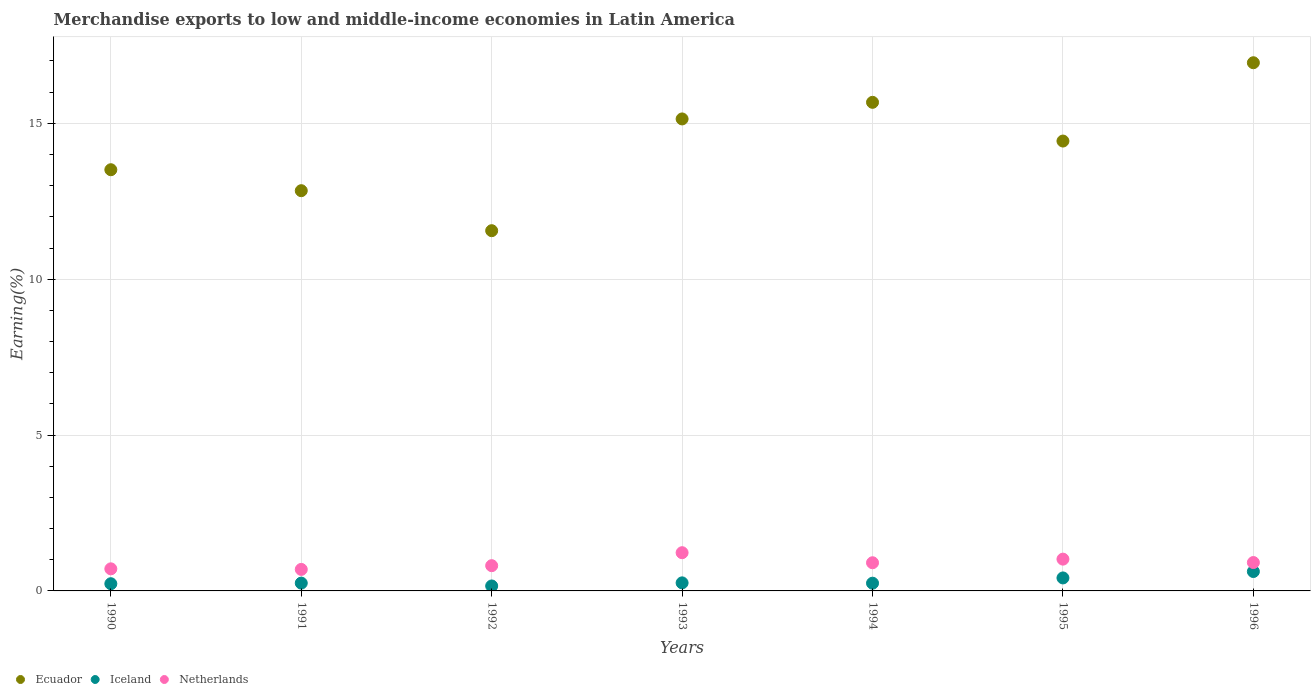How many different coloured dotlines are there?
Offer a very short reply. 3. What is the percentage of amount earned from merchandise exports in Netherlands in 1995?
Give a very brief answer. 1.02. Across all years, what is the maximum percentage of amount earned from merchandise exports in Ecuador?
Keep it short and to the point. 16.94. Across all years, what is the minimum percentage of amount earned from merchandise exports in Iceland?
Make the answer very short. 0.16. What is the total percentage of amount earned from merchandise exports in Iceland in the graph?
Ensure brevity in your answer.  2.19. What is the difference between the percentage of amount earned from merchandise exports in Ecuador in 1990 and that in 1994?
Offer a very short reply. -2.16. What is the difference between the percentage of amount earned from merchandise exports in Iceland in 1995 and the percentage of amount earned from merchandise exports in Ecuador in 1990?
Ensure brevity in your answer.  -13.1. What is the average percentage of amount earned from merchandise exports in Netherlands per year?
Offer a very short reply. 0.9. In the year 1995, what is the difference between the percentage of amount earned from merchandise exports in Ecuador and percentage of amount earned from merchandise exports in Netherlands?
Give a very brief answer. 13.41. What is the ratio of the percentage of amount earned from merchandise exports in Iceland in 1992 to that in 1996?
Your answer should be compact. 0.26. Is the percentage of amount earned from merchandise exports in Iceland in 1991 less than that in 1994?
Make the answer very short. No. What is the difference between the highest and the second highest percentage of amount earned from merchandise exports in Ecuador?
Ensure brevity in your answer.  1.27. What is the difference between the highest and the lowest percentage of amount earned from merchandise exports in Ecuador?
Your answer should be very brief. 5.39. In how many years, is the percentage of amount earned from merchandise exports in Netherlands greater than the average percentage of amount earned from merchandise exports in Netherlands taken over all years?
Keep it short and to the point. 4. Is the sum of the percentage of amount earned from merchandise exports in Netherlands in 1995 and 1996 greater than the maximum percentage of amount earned from merchandise exports in Ecuador across all years?
Your answer should be compact. No. Does the percentage of amount earned from merchandise exports in Iceland monotonically increase over the years?
Provide a succinct answer. No. Is the percentage of amount earned from merchandise exports in Ecuador strictly less than the percentage of amount earned from merchandise exports in Iceland over the years?
Make the answer very short. No. How many dotlines are there?
Make the answer very short. 3. Are the values on the major ticks of Y-axis written in scientific E-notation?
Give a very brief answer. No. Does the graph contain any zero values?
Your answer should be very brief. No. Where does the legend appear in the graph?
Keep it short and to the point. Bottom left. How many legend labels are there?
Give a very brief answer. 3. What is the title of the graph?
Offer a terse response. Merchandise exports to low and middle-income economies in Latin America. What is the label or title of the Y-axis?
Your response must be concise. Earning(%). What is the Earning(%) of Ecuador in 1990?
Your response must be concise. 13.51. What is the Earning(%) of Iceland in 1990?
Your answer should be compact. 0.23. What is the Earning(%) in Netherlands in 1990?
Provide a short and direct response. 0.71. What is the Earning(%) in Ecuador in 1991?
Your answer should be very brief. 12.84. What is the Earning(%) of Iceland in 1991?
Your answer should be very brief. 0.25. What is the Earning(%) in Netherlands in 1991?
Your answer should be compact. 0.69. What is the Earning(%) in Ecuador in 1992?
Give a very brief answer. 11.56. What is the Earning(%) of Iceland in 1992?
Provide a succinct answer. 0.16. What is the Earning(%) in Netherlands in 1992?
Your answer should be compact. 0.81. What is the Earning(%) in Ecuador in 1993?
Your answer should be very brief. 15.14. What is the Earning(%) in Iceland in 1993?
Offer a very short reply. 0.26. What is the Earning(%) in Netherlands in 1993?
Ensure brevity in your answer.  1.23. What is the Earning(%) of Ecuador in 1994?
Offer a terse response. 15.67. What is the Earning(%) in Iceland in 1994?
Keep it short and to the point. 0.25. What is the Earning(%) of Netherlands in 1994?
Ensure brevity in your answer.  0.9. What is the Earning(%) of Ecuador in 1995?
Give a very brief answer. 14.43. What is the Earning(%) of Iceland in 1995?
Provide a short and direct response. 0.42. What is the Earning(%) of Netherlands in 1995?
Your answer should be compact. 1.02. What is the Earning(%) in Ecuador in 1996?
Offer a terse response. 16.94. What is the Earning(%) in Iceland in 1996?
Make the answer very short. 0.62. What is the Earning(%) in Netherlands in 1996?
Keep it short and to the point. 0.91. Across all years, what is the maximum Earning(%) in Ecuador?
Keep it short and to the point. 16.94. Across all years, what is the maximum Earning(%) in Iceland?
Keep it short and to the point. 0.62. Across all years, what is the maximum Earning(%) in Netherlands?
Provide a short and direct response. 1.23. Across all years, what is the minimum Earning(%) of Ecuador?
Make the answer very short. 11.56. Across all years, what is the minimum Earning(%) in Iceland?
Your response must be concise. 0.16. Across all years, what is the minimum Earning(%) in Netherlands?
Provide a short and direct response. 0.69. What is the total Earning(%) in Ecuador in the graph?
Ensure brevity in your answer.  100.1. What is the total Earning(%) of Iceland in the graph?
Your answer should be very brief. 2.19. What is the total Earning(%) in Netherlands in the graph?
Ensure brevity in your answer.  6.27. What is the difference between the Earning(%) in Ecuador in 1990 and that in 1991?
Give a very brief answer. 0.67. What is the difference between the Earning(%) in Iceland in 1990 and that in 1991?
Keep it short and to the point. -0.02. What is the difference between the Earning(%) of Netherlands in 1990 and that in 1991?
Provide a succinct answer. 0.02. What is the difference between the Earning(%) of Ecuador in 1990 and that in 1992?
Your response must be concise. 1.96. What is the difference between the Earning(%) of Iceland in 1990 and that in 1992?
Give a very brief answer. 0.07. What is the difference between the Earning(%) in Netherlands in 1990 and that in 1992?
Give a very brief answer. -0.1. What is the difference between the Earning(%) of Ecuador in 1990 and that in 1993?
Your response must be concise. -1.63. What is the difference between the Earning(%) of Iceland in 1990 and that in 1993?
Give a very brief answer. -0.03. What is the difference between the Earning(%) of Netherlands in 1990 and that in 1993?
Your answer should be compact. -0.52. What is the difference between the Earning(%) in Ecuador in 1990 and that in 1994?
Make the answer very short. -2.16. What is the difference between the Earning(%) in Iceland in 1990 and that in 1994?
Give a very brief answer. -0.02. What is the difference between the Earning(%) in Netherlands in 1990 and that in 1994?
Provide a short and direct response. -0.2. What is the difference between the Earning(%) of Ecuador in 1990 and that in 1995?
Provide a succinct answer. -0.92. What is the difference between the Earning(%) in Iceland in 1990 and that in 1995?
Keep it short and to the point. -0.19. What is the difference between the Earning(%) in Netherlands in 1990 and that in 1995?
Keep it short and to the point. -0.31. What is the difference between the Earning(%) in Ecuador in 1990 and that in 1996?
Provide a short and direct response. -3.43. What is the difference between the Earning(%) in Iceland in 1990 and that in 1996?
Keep it short and to the point. -0.39. What is the difference between the Earning(%) of Netherlands in 1990 and that in 1996?
Give a very brief answer. -0.2. What is the difference between the Earning(%) of Ecuador in 1991 and that in 1992?
Keep it short and to the point. 1.28. What is the difference between the Earning(%) of Iceland in 1991 and that in 1992?
Ensure brevity in your answer.  0.09. What is the difference between the Earning(%) of Netherlands in 1991 and that in 1992?
Offer a terse response. -0.12. What is the difference between the Earning(%) in Ecuador in 1991 and that in 1993?
Ensure brevity in your answer.  -2.3. What is the difference between the Earning(%) in Iceland in 1991 and that in 1993?
Offer a terse response. -0.01. What is the difference between the Earning(%) of Netherlands in 1991 and that in 1993?
Your response must be concise. -0.54. What is the difference between the Earning(%) in Ecuador in 1991 and that in 1994?
Make the answer very short. -2.83. What is the difference between the Earning(%) of Iceland in 1991 and that in 1994?
Give a very brief answer. 0. What is the difference between the Earning(%) in Netherlands in 1991 and that in 1994?
Provide a succinct answer. -0.21. What is the difference between the Earning(%) in Ecuador in 1991 and that in 1995?
Keep it short and to the point. -1.59. What is the difference between the Earning(%) of Iceland in 1991 and that in 1995?
Offer a terse response. -0.17. What is the difference between the Earning(%) of Netherlands in 1991 and that in 1995?
Your answer should be compact. -0.33. What is the difference between the Earning(%) of Ecuador in 1991 and that in 1996?
Your answer should be compact. -4.1. What is the difference between the Earning(%) of Iceland in 1991 and that in 1996?
Offer a terse response. -0.37. What is the difference between the Earning(%) of Netherlands in 1991 and that in 1996?
Ensure brevity in your answer.  -0.22. What is the difference between the Earning(%) in Ecuador in 1992 and that in 1993?
Keep it short and to the point. -3.58. What is the difference between the Earning(%) in Iceland in 1992 and that in 1993?
Ensure brevity in your answer.  -0.1. What is the difference between the Earning(%) of Netherlands in 1992 and that in 1993?
Ensure brevity in your answer.  -0.42. What is the difference between the Earning(%) in Ecuador in 1992 and that in 1994?
Provide a succinct answer. -4.12. What is the difference between the Earning(%) in Iceland in 1992 and that in 1994?
Your response must be concise. -0.09. What is the difference between the Earning(%) of Netherlands in 1992 and that in 1994?
Offer a terse response. -0.09. What is the difference between the Earning(%) of Ecuador in 1992 and that in 1995?
Your answer should be compact. -2.88. What is the difference between the Earning(%) of Iceland in 1992 and that in 1995?
Provide a succinct answer. -0.26. What is the difference between the Earning(%) of Netherlands in 1992 and that in 1995?
Your answer should be very brief. -0.21. What is the difference between the Earning(%) of Ecuador in 1992 and that in 1996?
Give a very brief answer. -5.39. What is the difference between the Earning(%) of Iceland in 1992 and that in 1996?
Offer a terse response. -0.46. What is the difference between the Earning(%) of Netherlands in 1992 and that in 1996?
Provide a short and direct response. -0.1. What is the difference between the Earning(%) of Ecuador in 1993 and that in 1994?
Offer a terse response. -0.53. What is the difference between the Earning(%) in Iceland in 1993 and that in 1994?
Ensure brevity in your answer.  0.01. What is the difference between the Earning(%) of Netherlands in 1993 and that in 1994?
Provide a short and direct response. 0.32. What is the difference between the Earning(%) in Ecuador in 1993 and that in 1995?
Ensure brevity in your answer.  0.71. What is the difference between the Earning(%) of Iceland in 1993 and that in 1995?
Keep it short and to the point. -0.16. What is the difference between the Earning(%) in Netherlands in 1993 and that in 1995?
Keep it short and to the point. 0.21. What is the difference between the Earning(%) in Ecuador in 1993 and that in 1996?
Your response must be concise. -1.8. What is the difference between the Earning(%) in Iceland in 1993 and that in 1996?
Ensure brevity in your answer.  -0.36. What is the difference between the Earning(%) in Netherlands in 1993 and that in 1996?
Provide a succinct answer. 0.32. What is the difference between the Earning(%) in Ecuador in 1994 and that in 1995?
Give a very brief answer. 1.24. What is the difference between the Earning(%) of Iceland in 1994 and that in 1995?
Offer a terse response. -0.17. What is the difference between the Earning(%) in Netherlands in 1994 and that in 1995?
Your response must be concise. -0.12. What is the difference between the Earning(%) of Ecuador in 1994 and that in 1996?
Provide a succinct answer. -1.27. What is the difference between the Earning(%) of Iceland in 1994 and that in 1996?
Your answer should be very brief. -0.37. What is the difference between the Earning(%) in Netherlands in 1994 and that in 1996?
Give a very brief answer. -0.01. What is the difference between the Earning(%) in Ecuador in 1995 and that in 1996?
Your answer should be very brief. -2.51. What is the difference between the Earning(%) of Iceland in 1995 and that in 1996?
Provide a succinct answer. -0.21. What is the difference between the Earning(%) in Netherlands in 1995 and that in 1996?
Give a very brief answer. 0.11. What is the difference between the Earning(%) of Ecuador in 1990 and the Earning(%) of Iceland in 1991?
Provide a succinct answer. 13.26. What is the difference between the Earning(%) in Ecuador in 1990 and the Earning(%) in Netherlands in 1991?
Keep it short and to the point. 12.82. What is the difference between the Earning(%) in Iceland in 1990 and the Earning(%) in Netherlands in 1991?
Offer a terse response. -0.46. What is the difference between the Earning(%) in Ecuador in 1990 and the Earning(%) in Iceland in 1992?
Ensure brevity in your answer.  13.35. What is the difference between the Earning(%) of Ecuador in 1990 and the Earning(%) of Netherlands in 1992?
Provide a succinct answer. 12.7. What is the difference between the Earning(%) of Iceland in 1990 and the Earning(%) of Netherlands in 1992?
Your answer should be compact. -0.58. What is the difference between the Earning(%) in Ecuador in 1990 and the Earning(%) in Iceland in 1993?
Offer a very short reply. 13.25. What is the difference between the Earning(%) of Ecuador in 1990 and the Earning(%) of Netherlands in 1993?
Your response must be concise. 12.29. What is the difference between the Earning(%) in Iceland in 1990 and the Earning(%) in Netherlands in 1993?
Your answer should be very brief. -1. What is the difference between the Earning(%) in Ecuador in 1990 and the Earning(%) in Iceland in 1994?
Keep it short and to the point. 13.26. What is the difference between the Earning(%) in Ecuador in 1990 and the Earning(%) in Netherlands in 1994?
Your answer should be very brief. 12.61. What is the difference between the Earning(%) of Iceland in 1990 and the Earning(%) of Netherlands in 1994?
Give a very brief answer. -0.67. What is the difference between the Earning(%) of Ecuador in 1990 and the Earning(%) of Iceland in 1995?
Your answer should be compact. 13.1. What is the difference between the Earning(%) in Ecuador in 1990 and the Earning(%) in Netherlands in 1995?
Provide a succinct answer. 12.49. What is the difference between the Earning(%) of Iceland in 1990 and the Earning(%) of Netherlands in 1995?
Provide a succinct answer. -0.79. What is the difference between the Earning(%) of Ecuador in 1990 and the Earning(%) of Iceland in 1996?
Provide a succinct answer. 12.89. What is the difference between the Earning(%) in Ecuador in 1990 and the Earning(%) in Netherlands in 1996?
Provide a short and direct response. 12.6. What is the difference between the Earning(%) of Iceland in 1990 and the Earning(%) of Netherlands in 1996?
Keep it short and to the point. -0.68. What is the difference between the Earning(%) in Ecuador in 1991 and the Earning(%) in Iceland in 1992?
Give a very brief answer. 12.68. What is the difference between the Earning(%) of Ecuador in 1991 and the Earning(%) of Netherlands in 1992?
Provide a short and direct response. 12.03. What is the difference between the Earning(%) of Iceland in 1991 and the Earning(%) of Netherlands in 1992?
Your answer should be very brief. -0.56. What is the difference between the Earning(%) in Ecuador in 1991 and the Earning(%) in Iceland in 1993?
Offer a terse response. 12.58. What is the difference between the Earning(%) of Ecuador in 1991 and the Earning(%) of Netherlands in 1993?
Offer a very short reply. 11.61. What is the difference between the Earning(%) of Iceland in 1991 and the Earning(%) of Netherlands in 1993?
Your answer should be compact. -0.98. What is the difference between the Earning(%) in Ecuador in 1991 and the Earning(%) in Iceland in 1994?
Ensure brevity in your answer.  12.59. What is the difference between the Earning(%) in Ecuador in 1991 and the Earning(%) in Netherlands in 1994?
Offer a terse response. 11.94. What is the difference between the Earning(%) in Iceland in 1991 and the Earning(%) in Netherlands in 1994?
Ensure brevity in your answer.  -0.65. What is the difference between the Earning(%) of Ecuador in 1991 and the Earning(%) of Iceland in 1995?
Provide a succinct answer. 12.42. What is the difference between the Earning(%) of Ecuador in 1991 and the Earning(%) of Netherlands in 1995?
Your answer should be very brief. 11.82. What is the difference between the Earning(%) of Iceland in 1991 and the Earning(%) of Netherlands in 1995?
Ensure brevity in your answer.  -0.77. What is the difference between the Earning(%) of Ecuador in 1991 and the Earning(%) of Iceland in 1996?
Your answer should be very brief. 12.22. What is the difference between the Earning(%) of Ecuador in 1991 and the Earning(%) of Netherlands in 1996?
Offer a very short reply. 11.93. What is the difference between the Earning(%) in Iceland in 1991 and the Earning(%) in Netherlands in 1996?
Your response must be concise. -0.66. What is the difference between the Earning(%) of Ecuador in 1992 and the Earning(%) of Iceland in 1993?
Your response must be concise. 11.3. What is the difference between the Earning(%) of Ecuador in 1992 and the Earning(%) of Netherlands in 1993?
Offer a terse response. 10.33. What is the difference between the Earning(%) of Iceland in 1992 and the Earning(%) of Netherlands in 1993?
Give a very brief answer. -1.07. What is the difference between the Earning(%) in Ecuador in 1992 and the Earning(%) in Iceland in 1994?
Your answer should be compact. 11.31. What is the difference between the Earning(%) of Ecuador in 1992 and the Earning(%) of Netherlands in 1994?
Provide a short and direct response. 10.65. What is the difference between the Earning(%) of Iceland in 1992 and the Earning(%) of Netherlands in 1994?
Make the answer very short. -0.74. What is the difference between the Earning(%) in Ecuador in 1992 and the Earning(%) in Iceland in 1995?
Your answer should be compact. 11.14. What is the difference between the Earning(%) in Ecuador in 1992 and the Earning(%) in Netherlands in 1995?
Provide a succinct answer. 10.54. What is the difference between the Earning(%) of Iceland in 1992 and the Earning(%) of Netherlands in 1995?
Offer a very short reply. -0.86. What is the difference between the Earning(%) of Ecuador in 1992 and the Earning(%) of Iceland in 1996?
Your answer should be very brief. 10.93. What is the difference between the Earning(%) in Ecuador in 1992 and the Earning(%) in Netherlands in 1996?
Offer a terse response. 10.65. What is the difference between the Earning(%) of Iceland in 1992 and the Earning(%) of Netherlands in 1996?
Give a very brief answer. -0.75. What is the difference between the Earning(%) in Ecuador in 1993 and the Earning(%) in Iceland in 1994?
Your response must be concise. 14.89. What is the difference between the Earning(%) in Ecuador in 1993 and the Earning(%) in Netherlands in 1994?
Your answer should be very brief. 14.24. What is the difference between the Earning(%) of Iceland in 1993 and the Earning(%) of Netherlands in 1994?
Offer a terse response. -0.65. What is the difference between the Earning(%) in Ecuador in 1993 and the Earning(%) in Iceland in 1995?
Your answer should be very brief. 14.72. What is the difference between the Earning(%) of Ecuador in 1993 and the Earning(%) of Netherlands in 1995?
Provide a short and direct response. 14.12. What is the difference between the Earning(%) in Iceland in 1993 and the Earning(%) in Netherlands in 1995?
Keep it short and to the point. -0.76. What is the difference between the Earning(%) in Ecuador in 1993 and the Earning(%) in Iceland in 1996?
Keep it short and to the point. 14.52. What is the difference between the Earning(%) in Ecuador in 1993 and the Earning(%) in Netherlands in 1996?
Your answer should be compact. 14.23. What is the difference between the Earning(%) in Iceland in 1993 and the Earning(%) in Netherlands in 1996?
Your answer should be very brief. -0.65. What is the difference between the Earning(%) in Ecuador in 1994 and the Earning(%) in Iceland in 1995?
Your answer should be very brief. 15.26. What is the difference between the Earning(%) in Ecuador in 1994 and the Earning(%) in Netherlands in 1995?
Make the answer very short. 14.65. What is the difference between the Earning(%) of Iceland in 1994 and the Earning(%) of Netherlands in 1995?
Ensure brevity in your answer.  -0.77. What is the difference between the Earning(%) of Ecuador in 1994 and the Earning(%) of Iceland in 1996?
Provide a succinct answer. 15.05. What is the difference between the Earning(%) of Ecuador in 1994 and the Earning(%) of Netherlands in 1996?
Provide a short and direct response. 14.76. What is the difference between the Earning(%) in Iceland in 1994 and the Earning(%) in Netherlands in 1996?
Your answer should be compact. -0.66. What is the difference between the Earning(%) in Ecuador in 1995 and the Earning(%) in Iceland in 1996?
Your answer should be very brief. 13.81. What is the difference between the Earning(%) of Ecuador in 1995 and the Earning(%) of Netherlands in 1996?
Your answer should be compact. 13.52. What is the difference between the Earning(%) of Iceland in 1995 and the Earning(%) of Netherlands in 1996?
Offer a very short reply. -0.49. What is the average Earning(%) in Ecuador per year?
Your answer should be compact. 14.3. What is the average Earning(%) in Iceland per year?
Provide a succinct answer. 0.31. What is the average Earning(%) of Netherlands per year?
Give a very brief answer. 0.9. In the year 1990, what is the difference between the Earning(%) in Ecuador and Earning(%) in Iceland?
Provide a succinct answer. 13.28. In the year 1990, what is the difference between the Earning(%) of Ecuador and Earning(%) of Netherlands?
Your response must be concise. 12.8. In the year 1990, what is the difference between the Earning(%) in Iceland and Earning(%) in Netherlands?
Offer a terse response. -0.48. In the year 1991, what is the difference between the Earning(%) of Ecuador and Earning(%) of Iceland?
Make the answer very short. 12.59. In the year 1991, what is the difference between the Earning(%) of Ecuador and Earning(%) of Netherlands?
Offer a terse response. 12.15. In the year 1991, what is the difference between the Earning(%) in Iceland and Earning(%) in Netherlands?
Keep it short and to the point. -0.44. In the year 1992, what is the difference between the Earning(%) in Ecuador and Earning(%) in Iceland?
Offer a very short reply. 11.4. In the year 1992, what is the difference between the Earning(%) of Ecuador and Earning(%) of Netherlands?
Keep it short and to the point. 10.75. In the year 1992, what is the difference between the Earning(%) of Iceland and Earning(%) of Netherlands?
Your answer should be compact. -0.65. In the year 1993, what is the difference between the Earning(%) of Ecuador and Earning(%) of Iceland?
Make the answer very short. 14.88. In the year 1993, what is the difference between the Earning(%) of Ecuador and Earning(%) of Netherlands?
Your answer should be compact. 13.92. In the year 1993, what is the difference between the Earning(%) of Iceland and Earning(%) of Netherlands?
Give a very brief answer. -0.97. In the year 1994, what is the difference between the Earning(%) of Ecuador and Earning(%) of Iceland?
Keep it short and to the point. 15.43. In the year 1994, what is the difference between the Earning(%) in Ecuador and Earning(%) in Netherlands?
Ensure brevity in your answer.  14.77. In the year 1994, what is the difference between the Earning(%) in Iceland and Earning(%) in Netherlands?
Provide a short and direct response. -0.66. In the year 1995, what is the difference between the Earning(%) in Ecuador and Earning(%) in Iceland?
Keep it short and to the point. 14.02. In the year 1995, what is the difference between the Earning(%) in Ecuador and Earning(%) in Netherlands?
Make the answer very short. 13.41. In the year 1995, what is the difference between the Earning(%) in Iceland and Earning(%) in Netherlands?
Offer a very short reply. -0.6. In the year 1996, what is the difference between the Earning(%) in Ecuador and Earning(%) in Iceland?
Provide a succinct answer. 16.32. In the year 1996, what is the difference between the Earning(%) of Ecuador and Earning(%) of Netherlands?
Offer a terse response. 16.03. In the year 1996, what is the difference between the Earning(%) in Iceland and Earning(%) in Netherlands?
Provide a short and direct response. -0.29. What is the ratio of the Earning(%) of Ecuador in 1990 to that in 1991?
Provide a short and direct response. 1.05. What is the ratio of the Earning(%) in Iceland in 1990 to that in 1991?
Your answer should be very brief. 0.92. What is the ratio of the Earning(%) in Netherlands in 1990 to that in 1991?
Your answer should be compact. 1.03. What is the ratio of the Earning(%) in Ecuador in 1990 to that in 1992?
Give a very brief answer. 1.17. What is the ratio of the Earning(%) in Iceland in 1990 to that in 1992?
Make the answer very short. 1.45. What is the ratio of the Earning(%) in Netherlands in 1990 to that in 1992?
Your answer should be compact. 0.87. What is the ratio of the Earning(%) of Ecuador in 1990 to that in 1993?
Offer a terse response. 0.89. What is the ratio of the Earning(%) in Iceland in 1990 to that in 1993?
Give a very brief answer. 0.89. What is the ratio of the Earning(%) of Netherlands in 1990 to that in 1993?
Keep it short and to the point. 0.58. What is the ratio of the Earning(%) in Ecuador in 1990 to that in 1994?
Your answer should be very brief. 0.86. What is the ratio of the Earning(%) of Iceland in 1990 to that in 1994?
Make the answer very short. 0.93. What is the ratio of the Earning(%) of Netherlands in 1990 to that in 1994?
Ensure brevity in your answer.  0.78. What is the ratio of the Earning(%) of Ecuador in 1990 to that in 1995?
Give a very brief answer. 0.94. What is the ratio of the Earning(%) in Iceland in 1990 to that in 1995?
Offer a terse response. 0.55. What is the ratio of the Earning(%) of Netherlands in 1990 to that in 1995?
Your response must be concise. 0.69. What is the ratio of the Earning(%) of Ecuador in 1990 to that in 1996?
Offer a very short reply. 0.8. What is the ratio of the Earning(%) of Iceland in 1990 to that in 1996?
Offer a terse response. 0.37. What is the ratio of the Earning(%) of Netherlands in 1990 to that in 1996?
Keep it short and to the point. 0.78. What is the ratio of the Earning(%) of Ecuador in 1991 to that in 1992?
Keep it short and to the point. 1.11. What is the ratio of the Earning(%) in Iceland in 1991 to that in 1992?
Ensure brevity in your answer.  1.58. What is the ratio of the Earning(%) of Netherlands in 1991 to that in 1992?
Provide a succinct answer. 0.85. What is the ratio of the Earning(%) in Ecuador in 1991 to that in 1993?
Provide a short and direct response. 0.85. What is the ratio of the Earning(%) in Netherlands in 1991 to that in 1993?
Make the answer very short. 0.56. What is the ratio of the Earning(%) in Ecuador in 1991 to that in 1994?
Your answer should be compact. 0.82. What is the ratio of the Earning(%) of Iceland in 1991 to that in 1994?
Give a very brief answer. 1.01. What is the ratio of the Earning(%) in Netherlands in 1991 to that in 1994?
Provide a succinct answer. 0.76. What is the ratio of the Earning(%) of Ecuador in 1991 to that in 1995?
Your answer should be very brief. 0.89. What is the ratio of the Earning(%) of Iceland in 1991 to that in 1995?
Make the answer very short. 0.6. What is the ratio of the Earning(%) in Netherlands in 1991 to that in 1995?
Offer a very short reply. 0.68. What is the ratio of the Earning(%) in Ecuador in 1991 to that in 1996?
Offer a terse response. 0.76. What is the ratio of the Earning(%) in Iceland in 1991 to that in 1996?
Offer a very short reply. 0.4. What is the ratio of the Earning(%) of Netherlands in 1991 to that in 1996?
Keep it short and to the point. 0.76. What is the ratio of the Earning(%) of Ecuador in 1992 to that in 1993?
Make the answer very short. 0.76. What is the ratio of the Earning(%) of Iceland in 1992 to that in 1993?
Give a very brief answer. 0.62. What is the ratio of the Earning(%) in Netherlands in 1992 to that in 1993?
Make the answer very short. 0.66. What is the ratio of the Earning(%) in Ecuador in 1992 to that in 1994?
Make the answer very short. 0.74. What is the ratio of the Earning(%) in Iceland in 1992 to that in 1994?
Offer a very short reply. 0.64. What is the ratio of the Earning(%) of Netherlands in 1992 to that in 1994?
Ensure brevity in your answer.  0.9. What is the ratio of the Earning(%) in Ecuador in 1992 to that in 1995?
Your answer should be very brief. 0.8. What is the ratio of the Earning(%) of Iceland in 1992 to that in 1995?
Your answer should be very brief. 0.38. What is the ratio of the Earning(%) in Netherlands in 1992 to that in 1995?
Ensure brevity in your answer.  0.79. What is the ratio of the Earning(%) in Ecuador in 1992 to that in 1996?
Provide a succinct answer. 0.68. What is the ratio of the Earning(%) in Iceland in 1992 to that in 1996?
Provide a short and direct response. 0.26. What is the ratio of the Earning(%) of Netherlands in 1992 to that in 1996?
Your answer should be very brief. 0.89. What is the ratio of the Earning(%) of Iceland in 1993 to that in 1994?
Give a very brief answer. 1.04. What is the ratio of the Earning(%) of Netherlands in 1993 to that in 1994?
Provide a short and direct response. 1.36. What is the ratio of the Earning(%) in Ecuador in 1993 to that in 1995?
Your response must be concise. 1.05. What is the ratio of the Earning(%) of Iceland in 1993 to that in 1995?
Provide a short and direct response. 0.62. What is the ratio of the Earning(%) in Netherlands in 1993 to that in 1995?
Keep it short and to the point. 1.2. What is the ratio of the Earning(%) in Ecuador in 1993 to that in 1996?
Your response must be concise. 0.89. What is the ratio of the Earning(%) in Iceland in 1993 to that in 1996?
Make the answer very short. 0.42. What is the ratio of the Earning(%) of Netherlands in 1993 to that in 1996?
Offer a terse response. 1.35. What is the ratio of the Earning(%) of Ecuador in 1994 to that in 1995?
Your answer should be very brief. 1.09. What is the ratio of the Earning(%) in Iceland in 1994 to that in 1995?
Make the answer very short. 0.59. What is the ratio of the Earning(%) of Netherlands in 1994 to that in 1995?
Your response must be concise. 0.89. What is the ratio of the Earning(%) in Ecuador in 1994 to that in 1996?
Provide a short and direct response. 0.93. What is the ratio of the Earning(%) in Iceland in 1994 to that in 1996?
Ensure brevity in your answer.  0.4. What is the ratio of the Earning(%) in Ecuador in 1995 to that in 1996?
Provide a succinct answer. 0.85. What is the ratio of the Earning(%) in Iceland in 1995 to that in 1996?
Your answer should be very brief. 0.67. What is the ratio of the Earning(%) in Netherlands in 1995 to that in 1996?
Your answer should be compact. 1.12. What is the difference between the highest and the second highest Earning(%) of Ecuador?
Make the answer very short. 1.27. What is the difference between the highest and the second highest Earning(%) in Iceland?
Offer a terse response. 0.21. What is the difference between the highest and the second highest Earning(%) in Netherlands?
Give a very brief answer. 0.21. What is the difference between the highest and the lowest Earning(%) in Ecuador?
Your response must be concise. 5.39. What is the difference between the highest and the lowest Earning(%) of Iceland?
Your answer should be very brief. 0.46. What is the difference between the highest and the lowest Earning(%) of Netherlands?
Ensure brevity in your answer.  0.54. 